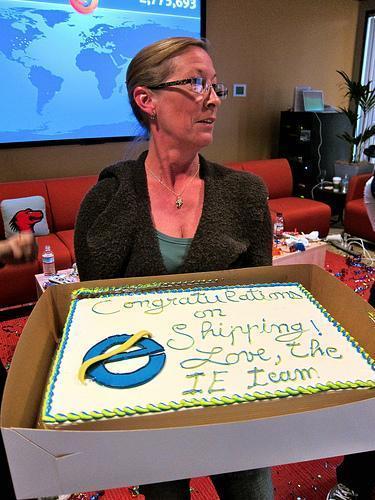How many cakes the woman holding?
Give a very brief answer. 1. 